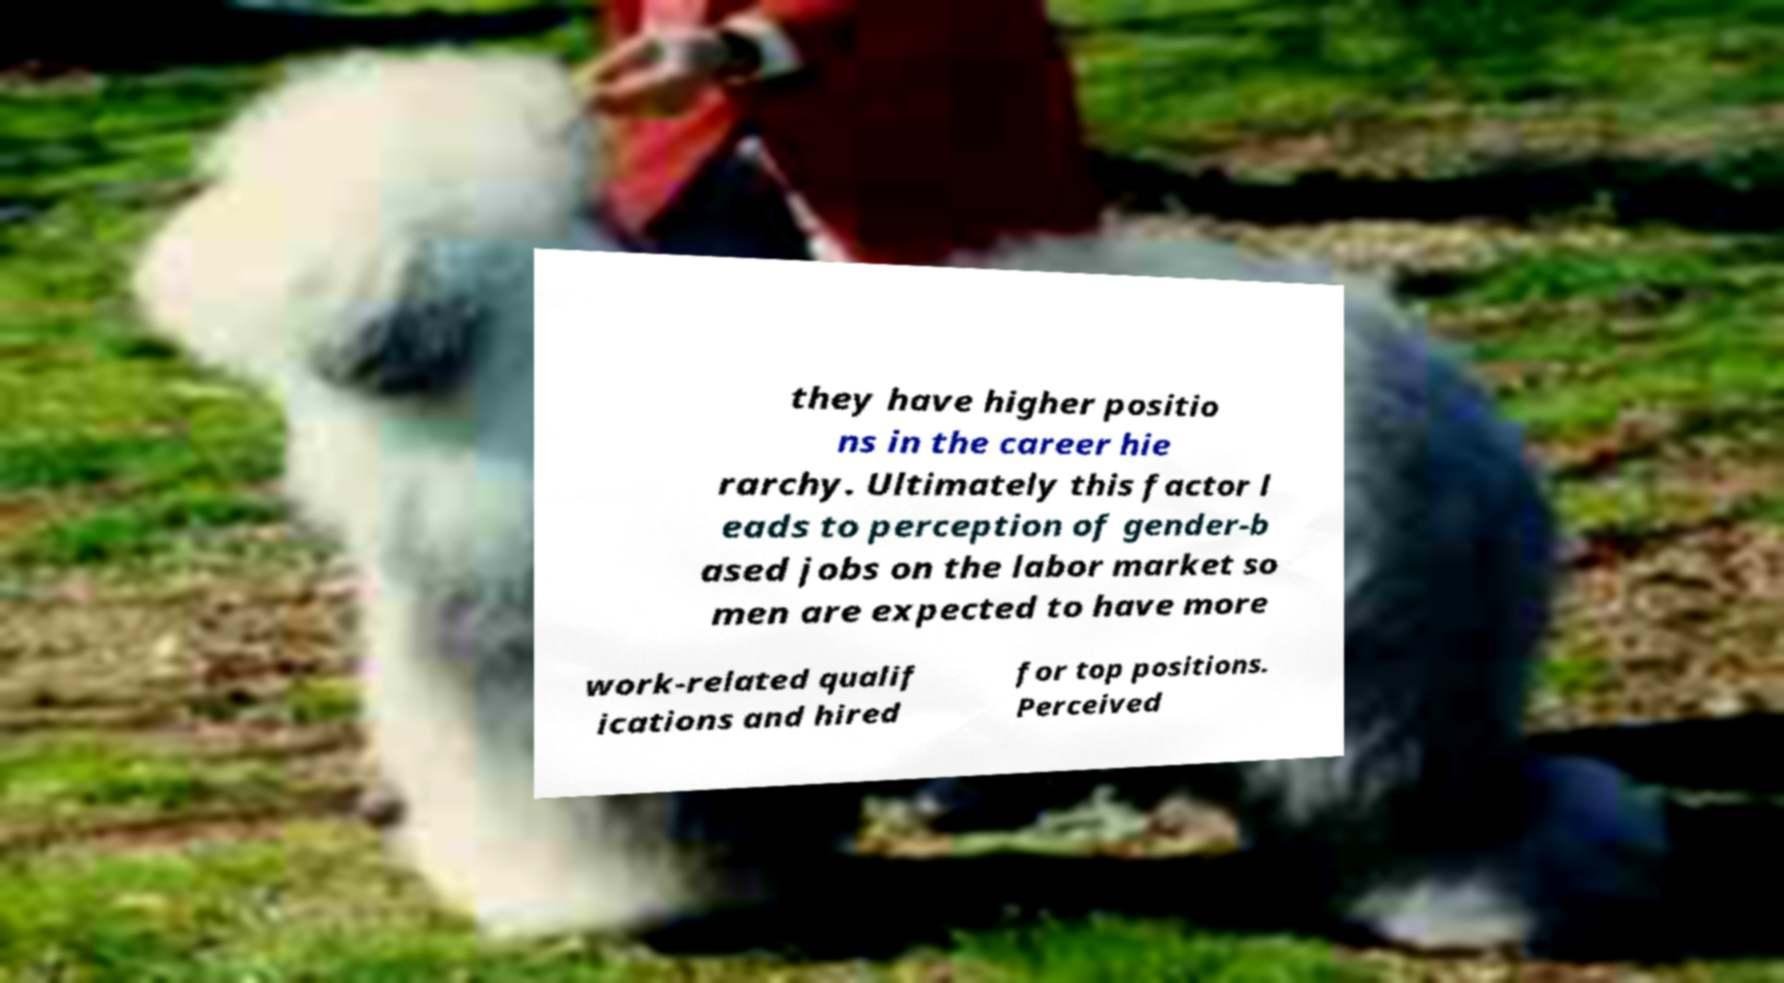What messages or text are displayed in this image? I need them in a readable, typed format. they have higher positio ns in the career hie rarchy. Ultimately this factor l eads to perception of gender-b ased jobs on the labor market so men are expected to have more work-related qualif ications and hired for top positions. Perceived 